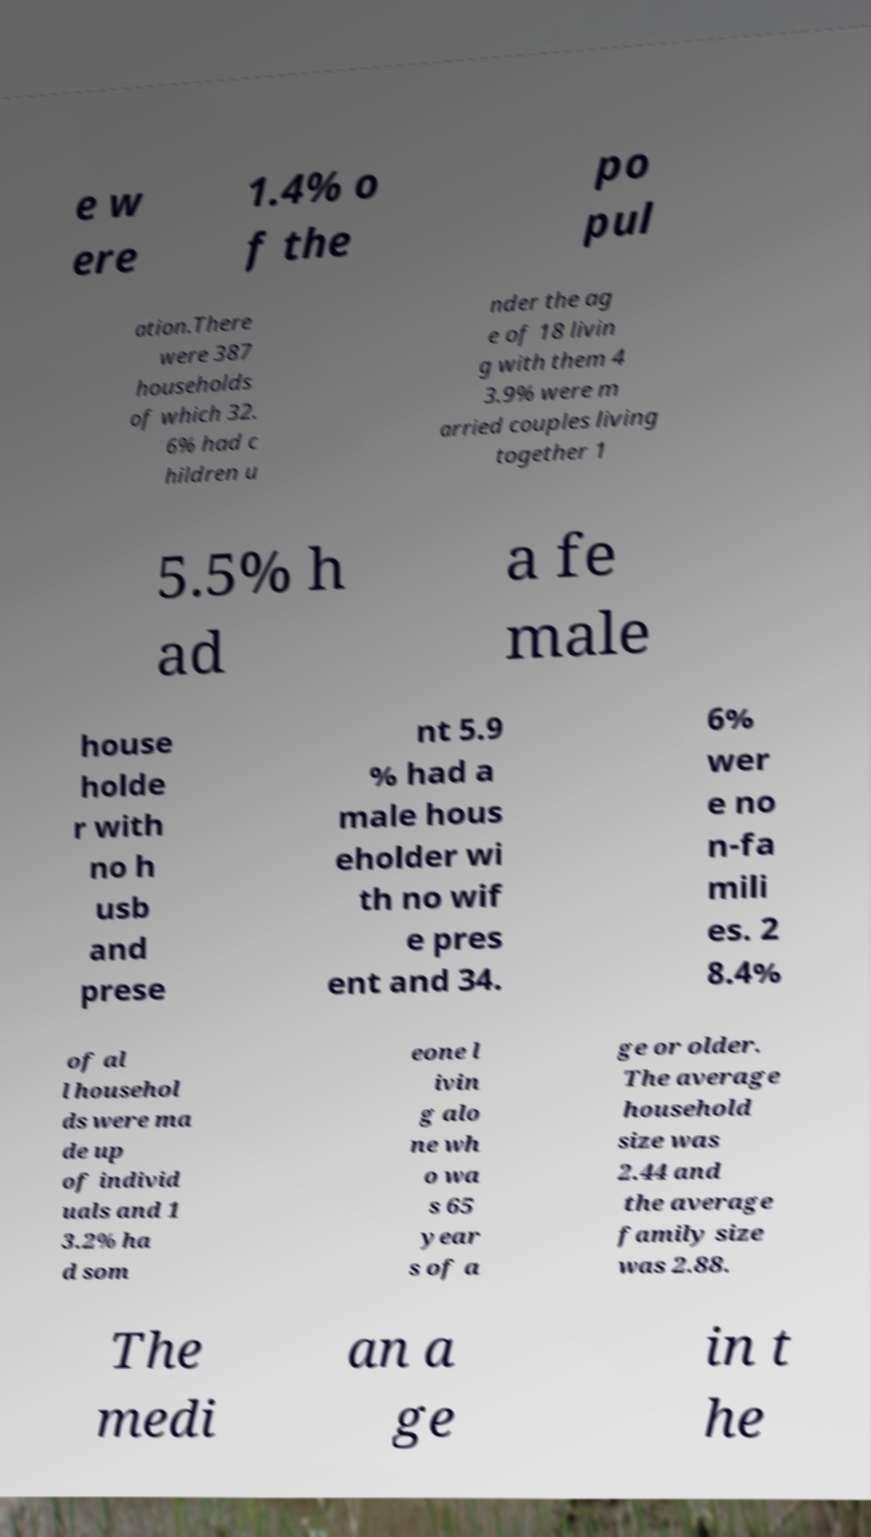Can you accurately transcribe the text from the provided image for me? e w ere 1.4% o f the po pul ation.There were 387 households of which 32. 6% had c hildren u nder the ag e of 18 livin g with them 4 3.9% were m arried couples living together 1 5.5% h ad a fe male house holde r with no h usb and prese nt 5.9 % had a male hous eholder wi th no wif e pres ent and 34. 6% wer e no n-fa mili es. 2 8.4% of al l househol ds were ma de up of individ uals and 1 3.2% ha d som eone l ivin g alo ne wh o wa s 65 year s of a ge or older. The average household size was 2.44 and the average family size was 2.88. The medi an a ge in t he 